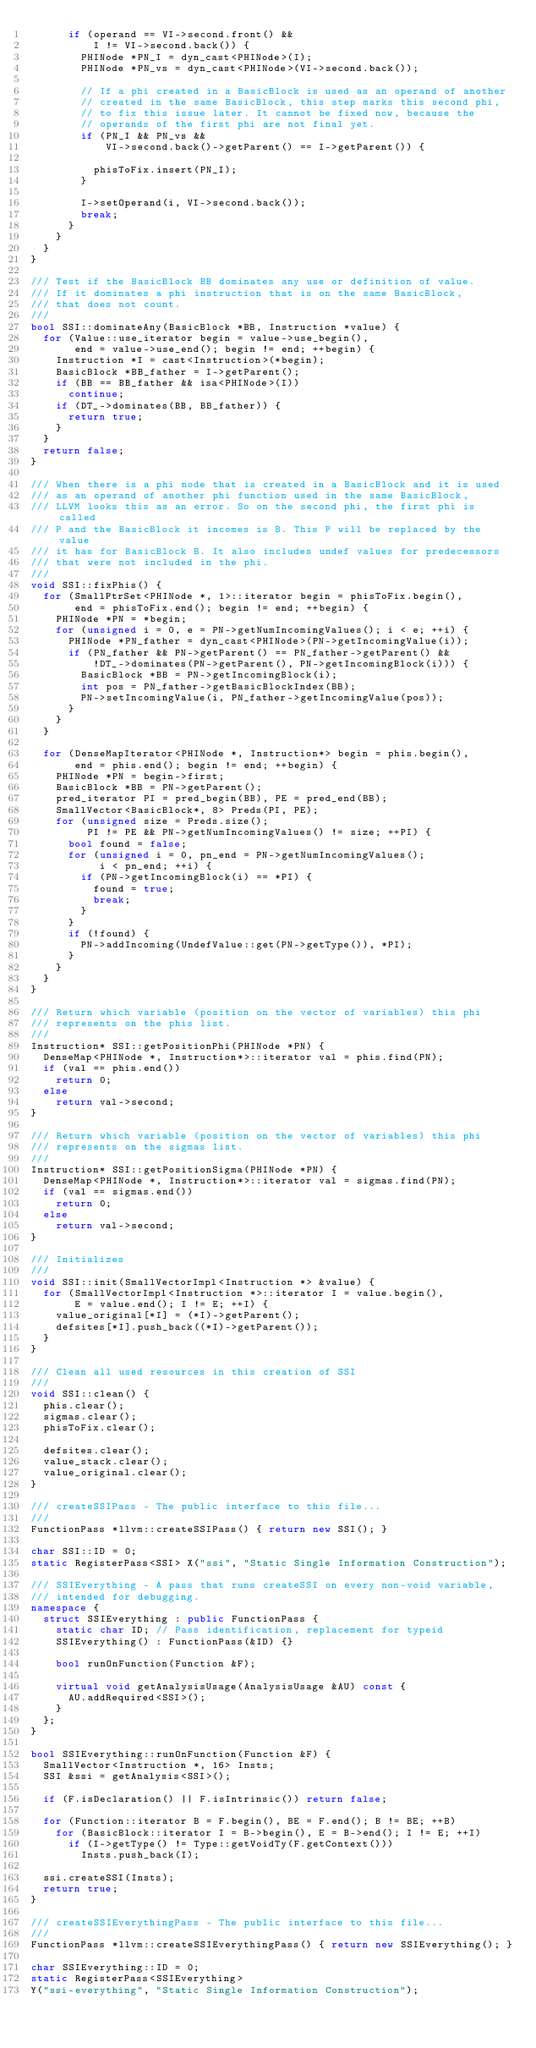Convert code to text. <code><loc_0><loc_0><loc_500><loc_500><_C++_>      if (operand == VI->second.front() &&
          I != VI->second.back()) {
        PHINode *PN_I = dyn_cast<PHINode>(I);
        PHINode *PN_vs = dyn_cast<PHINode>(VI->second.back());

        // If a phi created in a BasicBlock is used as an operand of another
        // created in the same BasicBlock, this step marks this second phi,
        // to fix this issue later. It cannot be fixed now, because the
        // operands of the first phi are not final yet.
        if (PN_I && PN_vs &&
            VI->second.back()->getParent() == I->getParent()) {

          phisToFix.insert(PN_I);
        }

        I->setOperand(i, VI->second.back());
        break;
      }
    }
  }
}

/// Test if the BasicBlock BB dominates any use or definition of value.
/// If it dominates a phi instruction that is on the same BasicBlock,
/// that does not count.
///
bool SSI::dominateAny(BasicBlock *BB, Instruction *value) {
  for (Value::use_iterator begin = value->use_begin(),
       end = value->use_end(); begin != end; ++begin) {
    Instruction *I = cast<Instruction>(*begin);
    BasicBlock *BB_father = I->getParent();
    if (BB == BB_father && isa<PHINode>(I))
      continue;
    if (DT_->dominates(BB, BB_father)) {
      return true;
    }
  }
  return false;
}

/// When there is a phi node that is created in a BasicBlock and it is used
/// as an operand of another phi function used in the same BasicBlock,
/// LLVM looks this as an error. So on the second phi, the first phi is called
/// P and the BasicBlock it incomes is B. This P will be replaced by the value
/// it has for BasicBlock B. It also includes undef values for predecessors
/// that were not included in the phi.
///
void SSI::fixPhis() {
  for (SmallPtrSet<PHINode *, 1>::iterator begin = phisToFix.begin(),
       end = phisToFix.end(); begin != end; ++begin) {
    PHINode *PN = *begin;
    for (unsigned i = 0, e = PN->getNumIncomingValues(); i < e; ++i) {
      PHINode *PN_father = dyn_cast<PHINode>(PN->getIncomingValue(i));
      if (PN_father && PN->getParent() == PN_father->getParent() &&
          !DT_->dominates(PN->getParent(), PN->getIncomingBlock(i))) {
        BasicBlock *BB = PN->getIncomingBlock(i);
        int pos = PN_father->getBasicBlockIndex(BB);
        PN->setIncomingValue(i, PN_father->getIncomingValue(pos));
      }
    }
  }

  for (DenseMapIterator<PHINode *, Instruction*> begin = phis.begin(),
       end = phis.end(); begin != end; ++begin) {
    PHINode *PN = begin->first;
    BasicBlock *BB = PN->getParent();
    pred_iterator PI = pred_begin(BB), PE = pred_end(BB);
    SmallVector<BasicBlock*, 8> Preds(PI, PE);
    for (unsigned size = Preds.size();
         PI != PE && PN->getNumIncomingValues() != size; ++PI) {
      bool found = false;
      for (unsigned i = 0, pn_end = PN->getNumIncomingValues();
           i < pn_end; ++i) {
        if (PN->getIncomingBlock(i) == *PI) {
          found = true;
          break;
        }
      }
      if (!found) {
        PN->addIncoming(UndefValue::get(PN->getType()), *PI);
      }
    }
  }
}

/// Return which variable (position on the vector of variables) this phi
/// represents on the phis list.
///
Instruction* SSI::getPositionPhi(PHINode *PN) {
  DenseMap<PHINode *, Instruction*>::iterator val = phis.find(PN);
  if (val == phis.end())
    return 0;
  else
    return val->second;
}

/// Return which variable (position on the vector of variables) this phi
/// represents on the sigmas list.
///
Instruction* SSI::getPositionSigma(PHINode *PN) {
  DenseMap<PHINode *, Instruction*>::iterator val = sigmas.find(PN);
  if (val == sigmas.end())
    return 0;
  else
    return val->second;
}

/// Initializes
///
void SSI::init(SmallVectorImpl<Instruction *> &value) {
  for (SmallVectorImpl<Instruction *>::iterator I = value.begin(),
       E = value.end(); I != E; ++I) {
    value_original[*I] = (*I)->getParent();
    defsites[*I].push_back((*I)->getParent());
  }
}

/// Clean all used resources in this creation of SSI
///
void SSI::clean() {
  phis.clear();
  sigmas.clear();
  phisToFix.clear();

  defsites.clear();
  value_stack.clear();
  value_original.clear();
}

/// createSSIPass - The public interface to this file...
///
FunctionPass *llvm::createSSIPass() { return new SSI(); }

char SSI::ID = 0;
static RegisterPass<SSI> X("ssi", "Static Single Information Construction");

/// SSIEverything - A pass that runs createSSI on every non-void variable,
/// intended for debugging.
namespace {
  struct SSIEverything : public FunctionPass {
    static char ID; // Pass identification, replacement for typeid
    SSIEverything() : FunctionPass(&ID) {}

    bool runOnFunction(Function &F);

    virtual void getAnalysisUsage(AnalysisUsage &AU) const {
      AU.addRequired<SSI>();
    }
  };
}

bool SSIEverything::runOnFunction(Function &F) {
  SmallVector<Instruction *, 16> Insts;
  SSI &ssi = getAnalysis<SSI>();

  if (F.isDeclaration() || F.isIntrinsic()) return false;

  for (Function::iterator B = F.begin(), BE = F.end(); B != BE; ++B)
    for (BasicBlock::iterator I = B->begin(), E = B->end(); I != E; ++I)
      if (I->getType() != Type::getVoidTy(F.getContext()))
        Insts.push_back(I);

  ssi.createSSI(Insts);
  return true;
}

/// createSSIEverythingPass - The public interface to this file...
///
FunctionPass *llvm::createSSIEverythingPass() { return new SSIEverything(); }

char SSIEverything::ID = 0;
static RegisterPass<SSIEverything>
Y("ssi-everything", "Static Single Information Construction");
</code> 